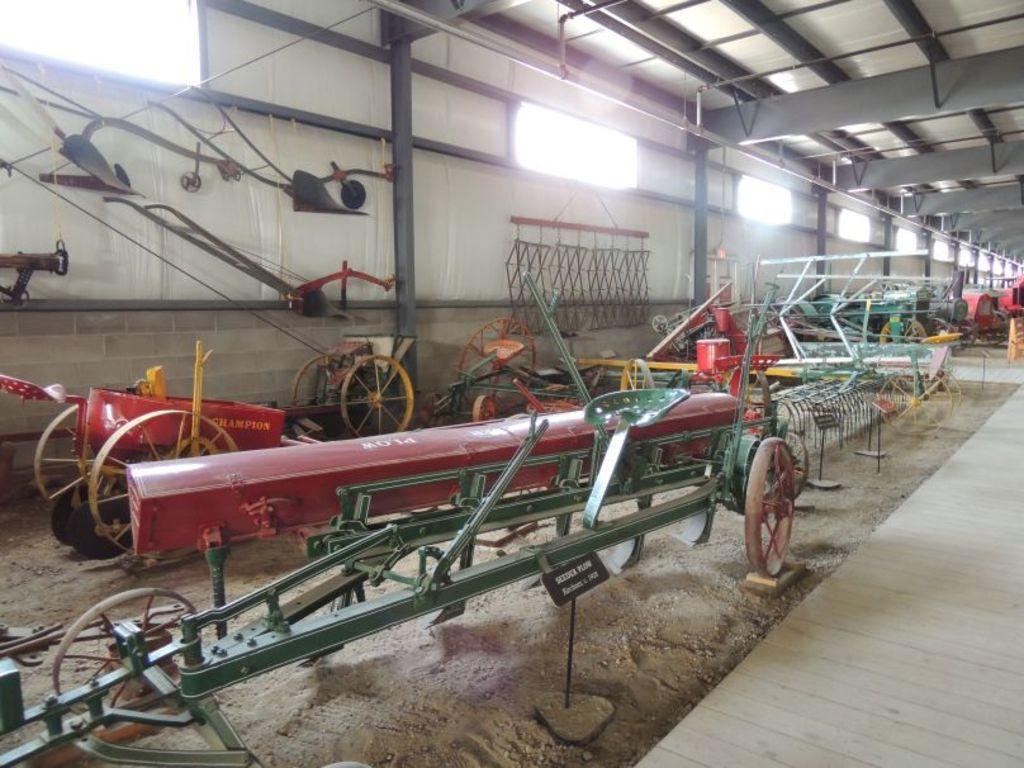Describe this image in one or two sentences. This picture shows the inner view of a shed, some objects attached to the ceiling, some objects attached to the wall, some boards with text attached to the poles, some objects looks like vehicles on the ground, some objects on the ground and one wooden object on the bottom right side of the image. 